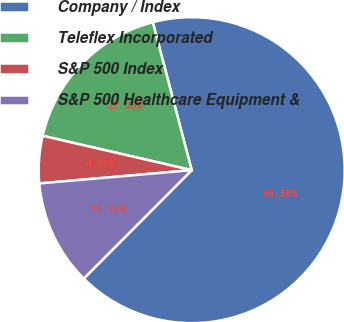Convert chart. <chart><loc_0><loc_0><loc_500><loc_500><pie_chart><fcel>Company / Index<fcel>Teleflex Incorporated<fcel>S&P 500 Index<fcel>S&P 500 Healthcare Equipment &<nl><fcel>66.56%<fcel>17.3%<fcel>4.99%<fcel>11.15%<nl></chart> 